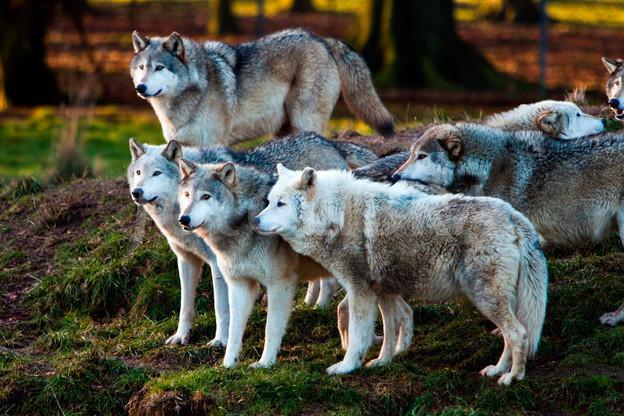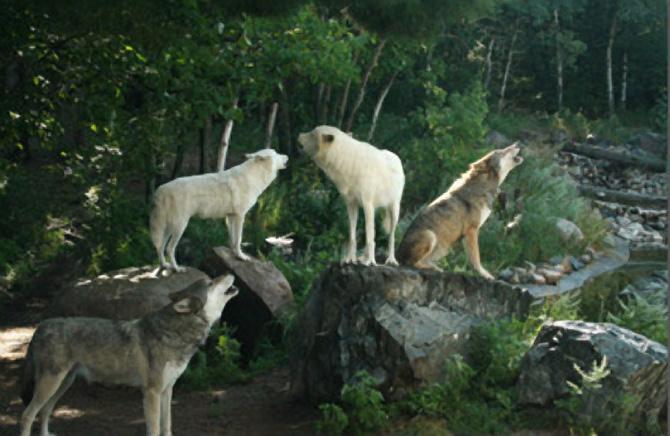The first image is the image on the left, the second image is the image on the right. For the images displayed, is the sentence "One image contains four wolves, several of which are perched on large grey rocks, and several facing rightward with heads high." factually correct? Answer yes or no. Yes. 